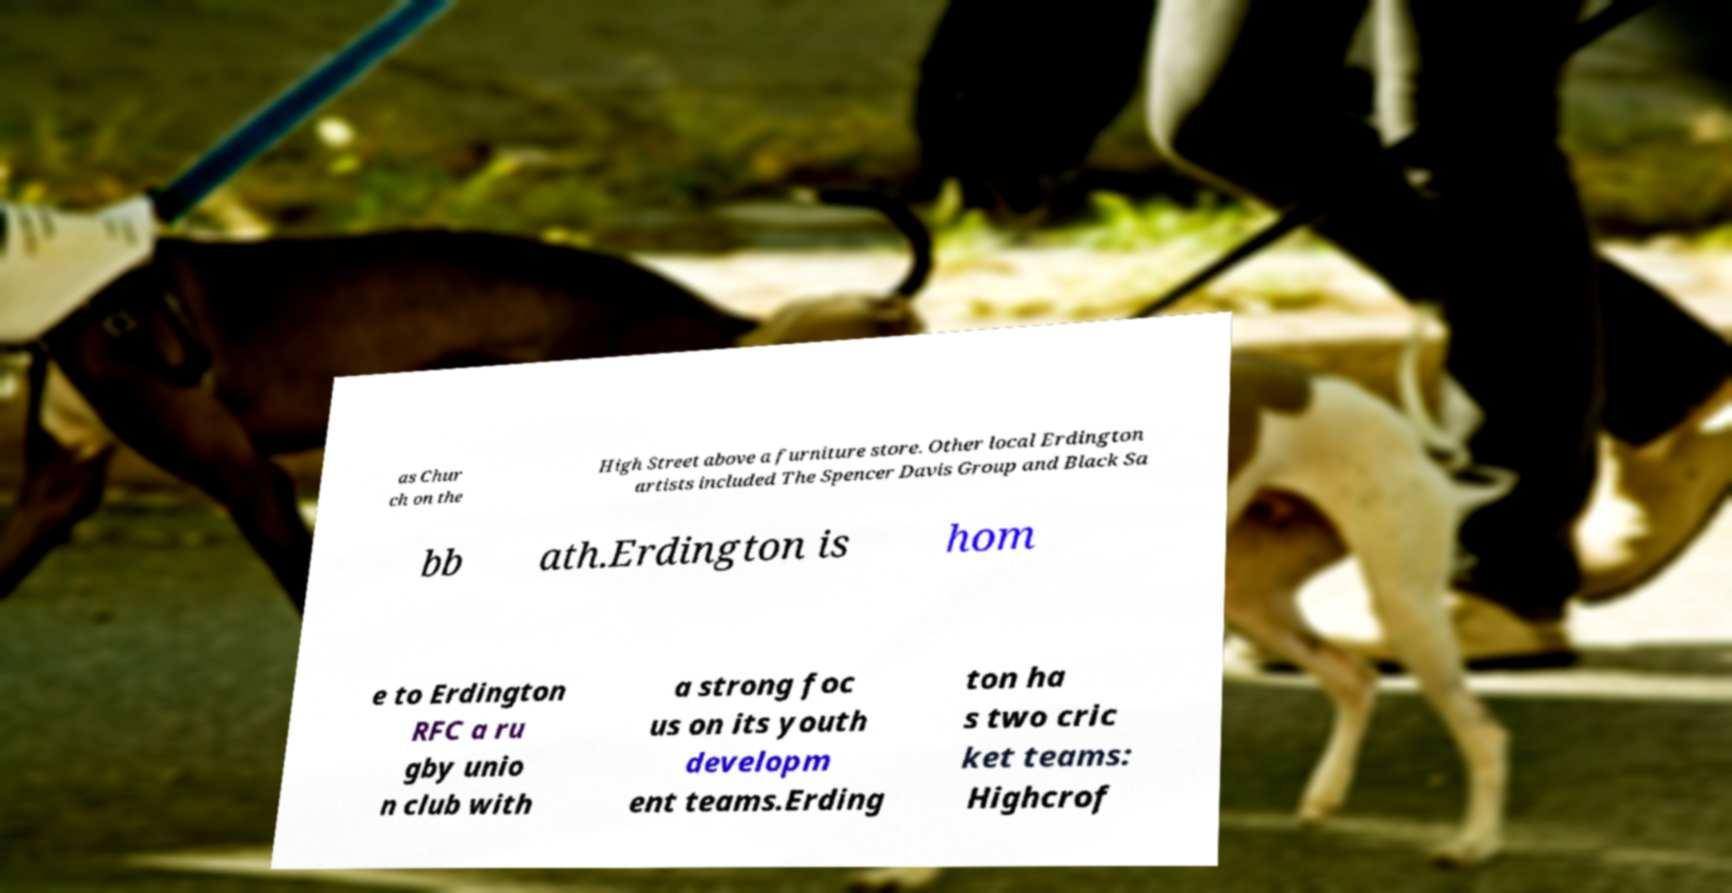What messages or text are displayed in this image? I need them in a readable, typed format. as Chur ch on the High Street above a furniture store. Other local Erdington artists included The Spencer Davis Group and Black Sa bb ath.Erdington is hom e to Erdington RFC a ru gby unio n club with a strong foc us on its youth developm ent teams.Erding ton ha s two cric ket teams: Highcrof 